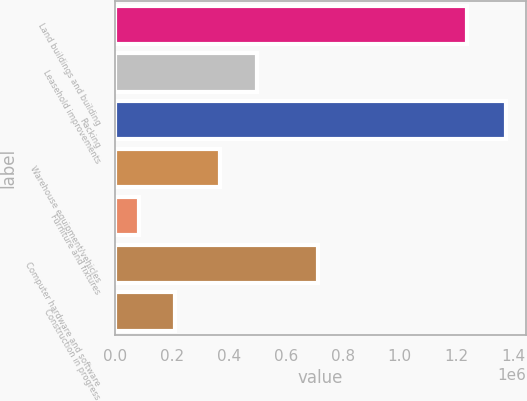<chart> <loc_0><loc_0><loc_500><loc_500><bar_chart><fcel>Land buildings and building<fcel>Leasehold improvements<fcel>Racking<fcel>Warehouse equipment/vehicles<fcel>Furniture and fixtures<fcel>Computer hardware and software<fcel>Construction in progress<nl><fcel>1.23517e+06<fcel>497898<fcel>1.37482e+06<fcel>368710<fcel>82941<fcel>713065<fcel>212129<nl></chart> 